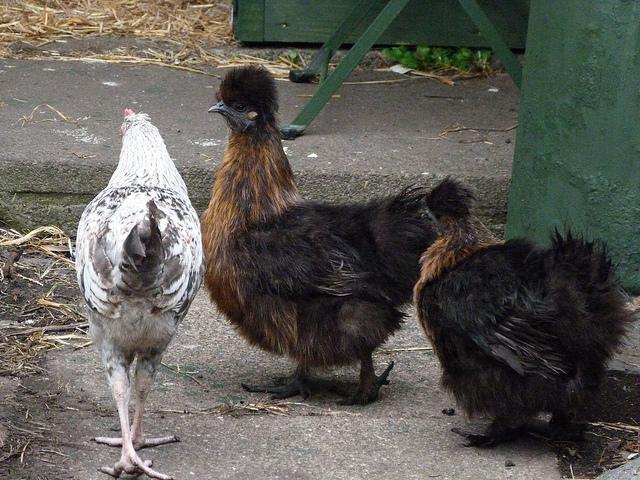How many birds?
Short answer required. 3. Are the birds adults?
Short answer required. Yes. Is this a male or female bird?
Be succinct. Female. What type of birds are these?
Short answer required. Chickens. How many birds are the same color?
Keep it brief. 2. 